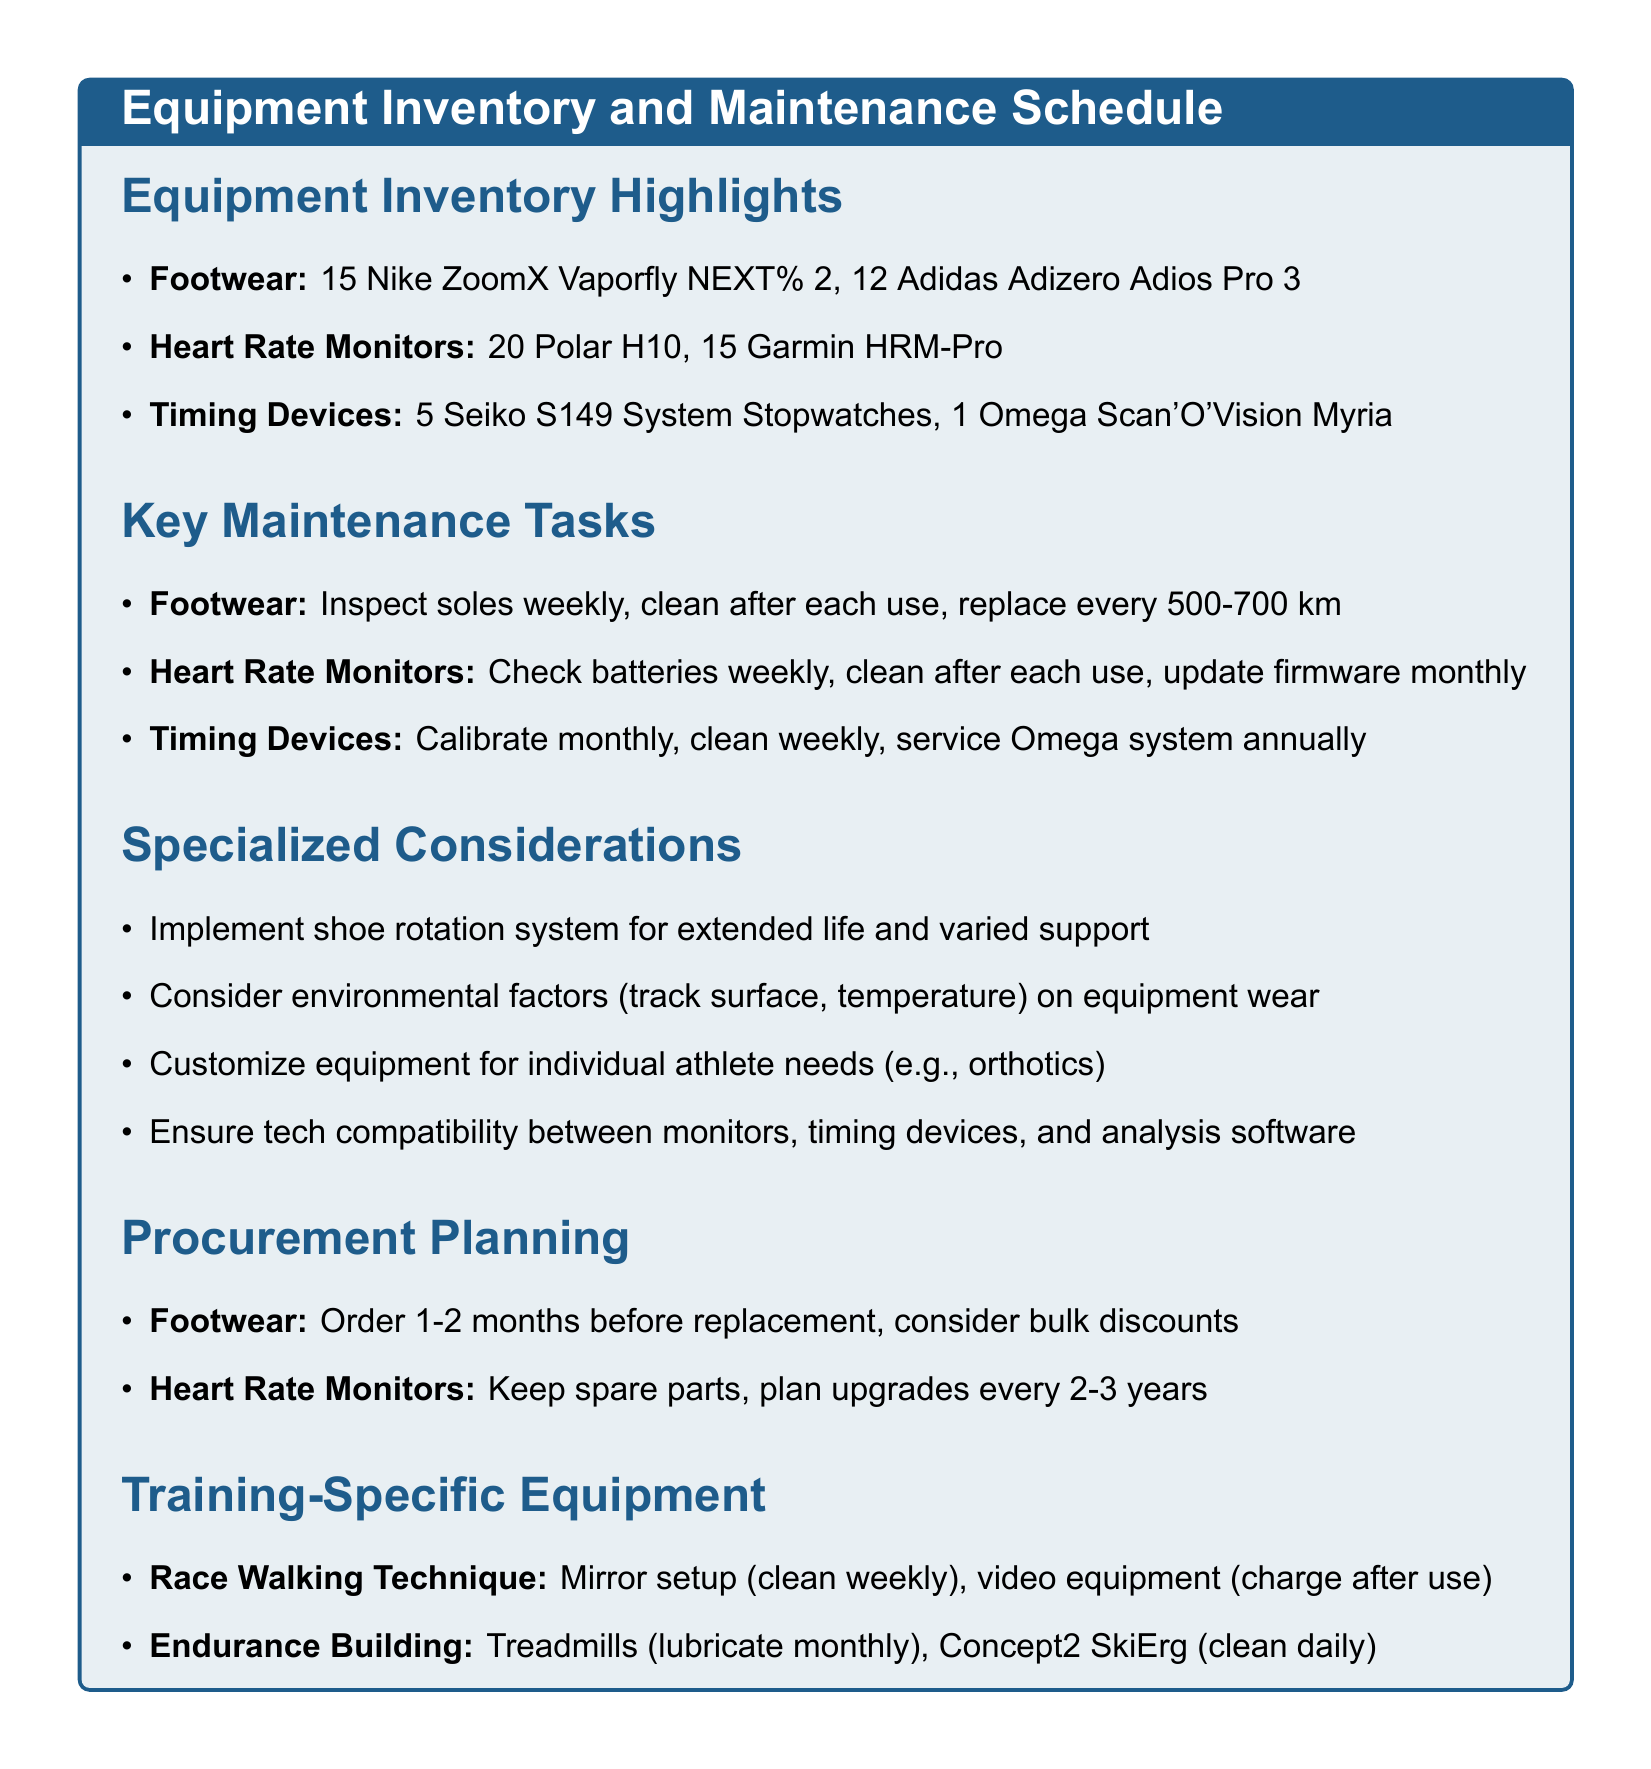What is the quantity of Nike ZoomX Vaporfly NEXT% 2? The quantity is specifically mentioned under the footwear section of the inventory.
Answer: 15 How often should heart rate monitors' straps and sensors be cleaned? This frequency is indicated in the maintenance tasks section for heart rate monitors.
Answer: After each use What is the size range for Adidas Adizero Adios Pro 3? This information is provided under the footwear category in the equipment inventory.
Answer: 39-45 EU How many Seiko S149 System Stopwatches are available? The specific count is listed in the timing devices section of the inventory.
Answer: 5 What task should be performed on footwear every 500-700 km? This is stated in the maintenance schedule for footwear regarding shoe replacement.
Answer: Replace shoes What is one specialized consideration mentioned for equipment? The document lists several considerations; this requires identifying one.
Answer: Shoe rotation How frequently should the Omega Scan'O'Vision be serviced? This maintenance task is specifically mentioned in the timing devices section.
Answer: Annually What is the frequency for lubricating the treadmill belt? This maintenance requirement is part of the endurance building equipment section.
Answer: Monthly 